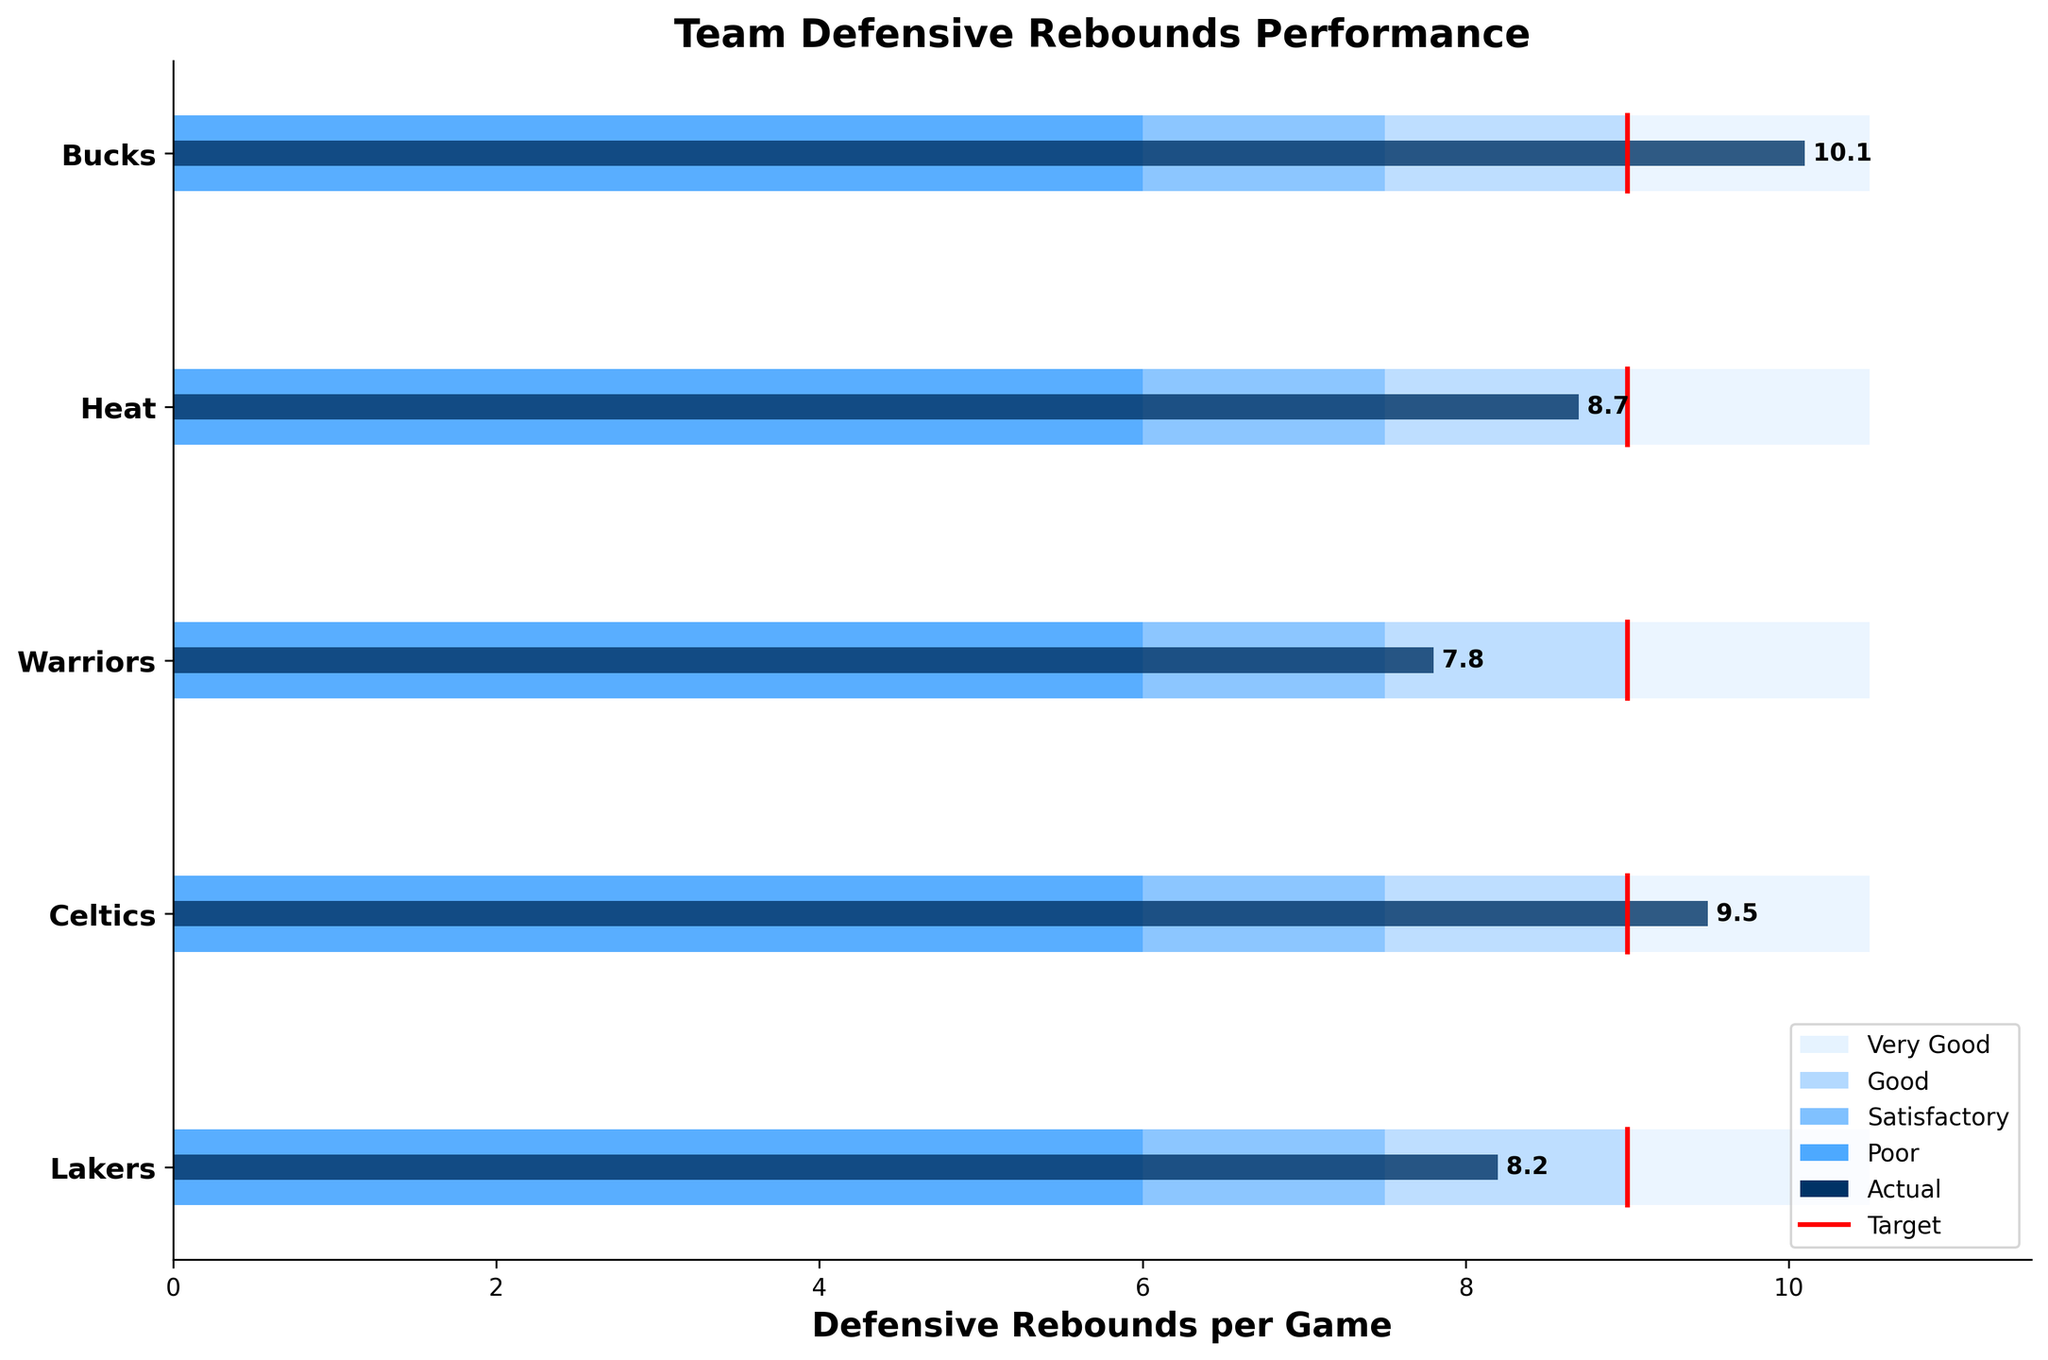Which team has the highest actual defensive rebounds per game? By looking at the bars representing the actual values, the team with the longest bar has the highest actual defensive rebounds per game. The Bucks have the highest actual value at 10.1 rebounds per game.
Answer: Bucks What is the average target defensive rebounds per game for all teams? Sum the target defensive rebounds per game for all teams and divide by the number of teams: (9.0 + 9.0 + 9.0 + 9.0 + 9.0) / 5 = 45 / 5 = 9.0
Answer: 9.0 Which team falls short of the target defensive rebounds per game the most? Compare the difference between actual and target values for each team. The Warriors have the largest negative difference: 7.8 (actual) - 9.0 (target) = -1.2
Answer: Warriors Across all teams, which team’s actual defensive rebounds are within the range of "Good" performance? "Good" performance is between 9.0 and 10.5 rebounds per game. The Heat’s actual value, 8.7, falls short of this range, but the Celtics' actual value, 9.5, falls within this range.
Answer: Celtics How many teams have a “Very Good” target range that is greater than their actual defensive rebounds per game? Count the teams where the actual defensive rebounds are less than the lower limit of the "Very Good" range (9.0). Teams: Lakers (8.2), Heat (8.7), Warriors (7.8).
Answer: 3 Which team had the actual performance closest to the satisfactory upper limit? The satisfactory upper limit is 7.5. The team with the closest actual value to this is the Lakers with 8.2 rebounds per game, but not exceeding 7.5. Thus, reassess another range. None fit this exact category, thus difficult threshold balance.
Answer: None accurate What is the overall range of defensive rebounds for all teams (from lowest to highest actual values)? Identify the lowest and highest actual values among the teams and calculate the range. Lowest is Warriors (7.8) and highest is Bucks (10.1). Range: 10.1 - 7.8 = 2.3
Answer: 2.3 Which teams met or exceeded their target defensive rebounds per game? Compare actual values with the target for each team. Teams that meet or exceed their targets are the Bucks (10.1) and Celtics (9.5).
Answer: Bucks, Celtics 